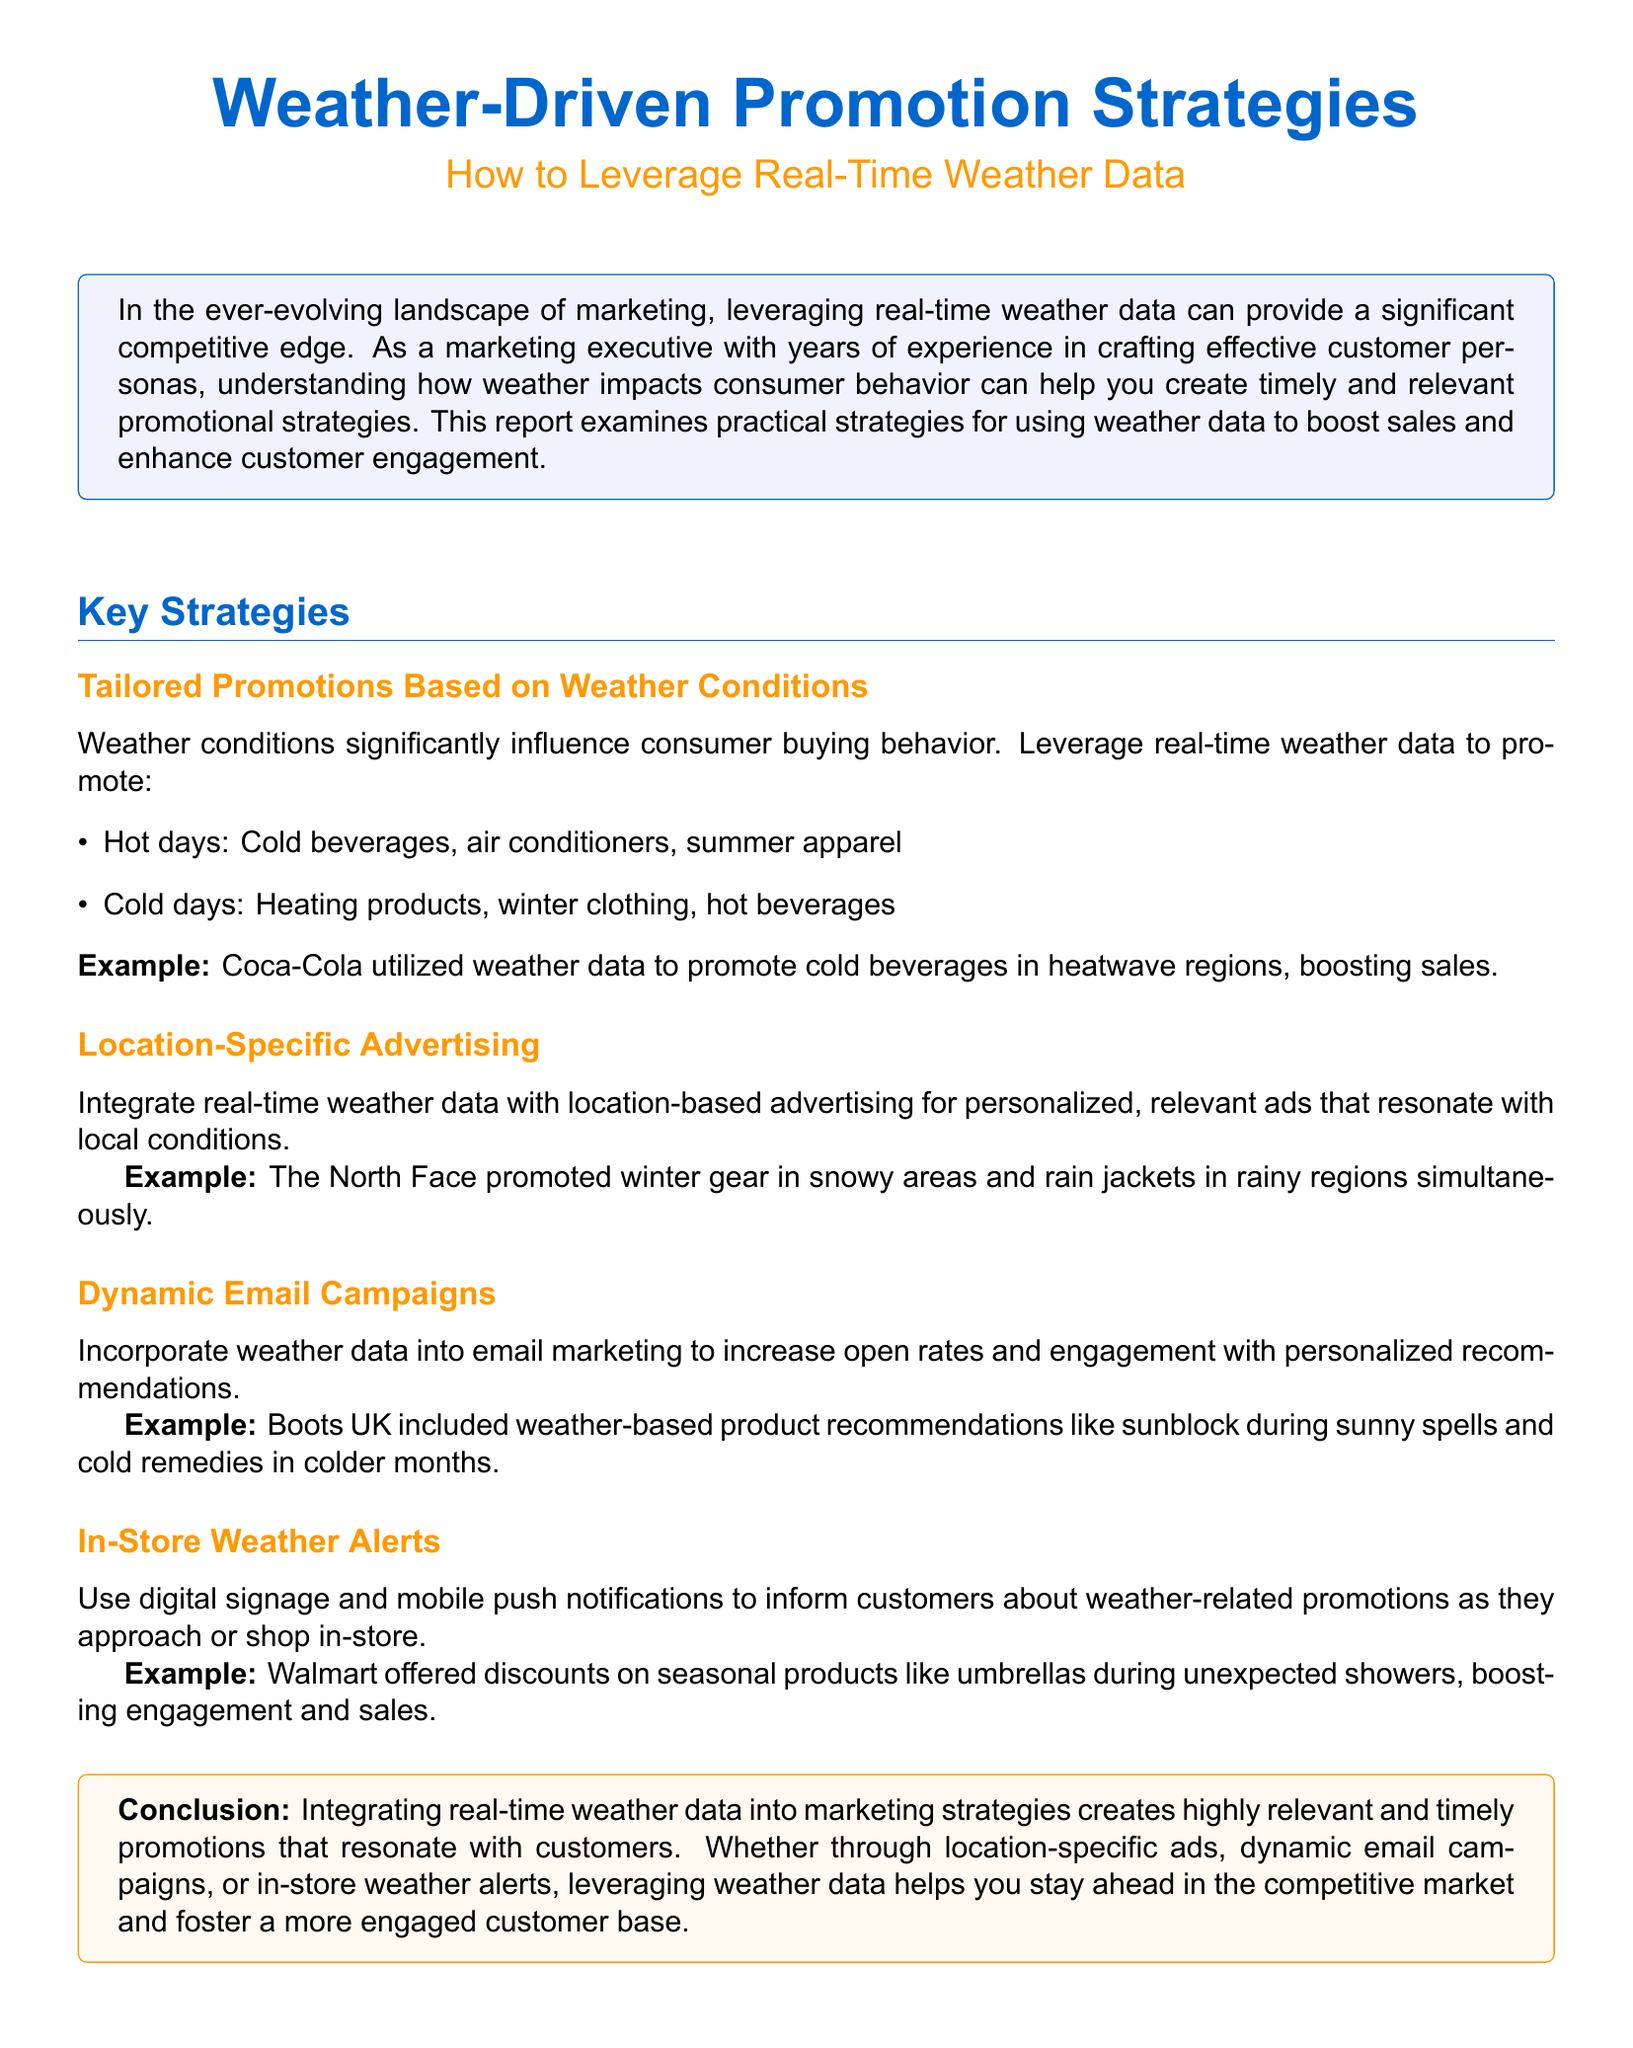What are some items promoted on hot days? The document lists cold beverages, air conditioners, and summer apparel as items promoted on hot days.
Answer: Cold beverages, air conditioners, summer apparel What example is provided for tailored promotions? Coca-Cola is mentioned as an example that utilized weather data to promote cold beverages in heatwave regions.
Answer: Coca-Cola What type of advertising can integrate real-time weather data? The document mentions location-specific advertising as a strategy that can integrate real-time weather data.
Answer: Location-specific advertising What weather-related product did Boots UK recommend during sunny spells? The example mentions that Boots UK included sunblock in their weather-based product recommendations during sunny spells.
Answer: Sunblock How does Walmart utilize weather data in-store? Walmart offered discounts on seasonal products like umbrellas during unexpected showers, showcasing how they utilize weather data in-store.
Answer: Discounts on umbrellas What is the primary benefit of integrating weather data into marketing strategies? The document highlights that it creates highly relevant and timely promotions, indicating the primary benefit of using weather data.
Answer: Highly relevant and timely promotions What is the conclusion about leveraging weather data? The conclusion emphasizes that leveraging weather data helps stay ahead in the competitive market and fosters a more engaged customer base.
Answer: Stay ahead in the competitive market What type of campaigns can be enhanced with weather data? Dynamic email campaigns can be incorporated with weather data to increase engagement and open rates.
Answer: Dynamic email campaigns 